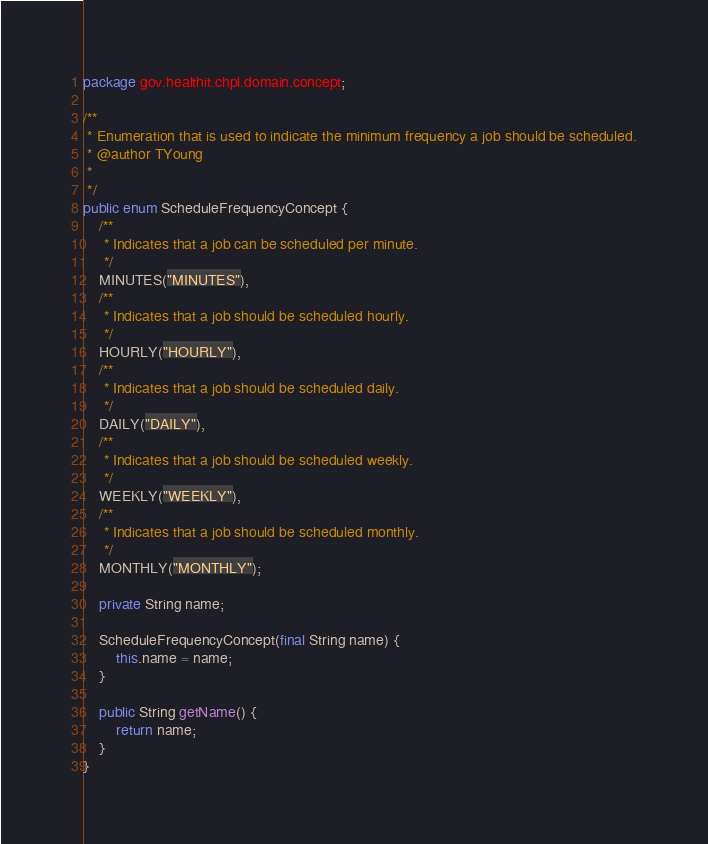<code> <loc_0><loc_0><loc_500><loc_500><_Java_>package gov.healthit.chpl.domain.concept;

/**
 * Enumeration that is used to indicate the minimum frequency a job should be scheduled.
 * @author TYoung
 *
 */
public enum ScheduleFrequencyConcept {
    /**
     * Indicates that a job can be scheduled per minute.
     */
    MINUTES("MINUTES"),
    /**
     * Indicates that a job should be scheduled hourly.
     */
    HOURLY("HOURLY"),
    /**
     * Indicates that a job should be scheduled daily.
     */
    DAILY("DAILY"),
    /**
     * Indicates that a job should be scheduled weekly.
     */
    WEEKLY("WEEKLY"),
    /**
     * Indicates that a job should be scheduled monthly.
     */
    MONTHLY("MONTHLY");

    private String name;

    ScheduleFrequencyConcept(final String name) {
        this.name = name;
    }

    public String getName() {
        return name;
    }
}
</code> 